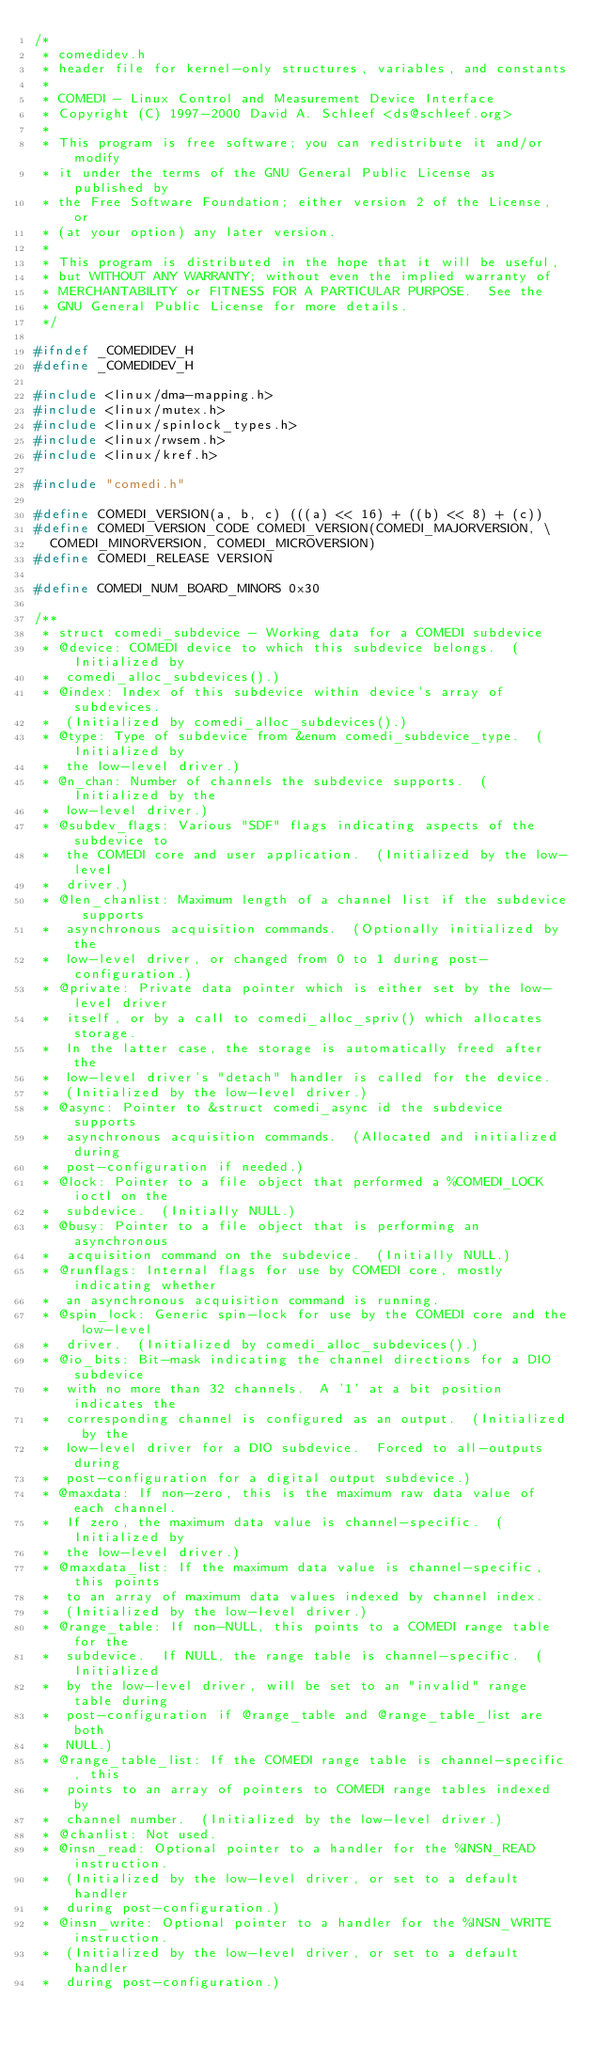Convert code to text. <code><loc_0><loc_0><loc_500><loc_500><_C_>/*
 * comedidev.h
 * header file for kernel-only structures, variables, and constants
 *
 * COMEDI - Linux Control and Measurement Device Interface
 * Copyright (C) 1997-2000 David A. Schleef <ds@schleef.org>
 *
 * This program is free software; you can redistribute it and/or modify
 * it under the terms of the GNU General Public License as published by
 * the Free Software Foundation; either version 2 of the License, or
 * (at your option) any later version.
 *
 * This program is distributed in the hope that it will be useful,
 * but WITHOUT ANY WARRANTY; without even the implied warranty of
 * MERCHANTABILITY or FITNESS FOR A PARTICULAR PURPOSE.  See the
 * GNU General Public License for more details.
 */

#ifndef _COMEDIDEV_H
#define _COMEDIDEV_H

#include <linux/dma-mapping.h>
#include <linux/mutex.h>
#include <linux/spinlock_types.h>
#include <linux/rwsem.h>
#include <linux/kref.h>

#include "comedi.h"

#define COMEDI_VERSION(a, b, c) (((a) << 16) + ((b) << 8) + (c))
#define COMEDI_VERSION_CODE COMEDI_VERSION(COMEDI_MAJORVERSION, \
	COMEDI_MINORVERSION, COMEDI_MICROVERSION)
#define COMEDI_RELEASE VERSION

#define COMEDI_NUM_BOARD_MINORS 0x30

/**
 * struct comedi_subdevice - Working data for a COMEDI subdevice
 * @device: COMEDI device to which this subdevice belongs.  (Initialized by
 *	comedi_alloc_subdevices().)
 * @index: Index of this subdevice within device's array of subdevices.
 *	(Initialized by comedi_alloc_subdevices().)
 * @type: Type of subdevice from &enum comedi_subdevice_type.  (Initialized by
 *	the low-level driver.)
 * @n_chan: Number of channels the subdevice supports.  (Initialized by the
 *	low-level driver.)
 * @subdev_flags: Various "SDF" flags indicating aspects of the subdevice to
 *	the COMEDI core and user application.  (Initialized by the low-level
 *	driver.)
 * @len_chanlist: Maximum length of a channel list if the subdevice supports
 *	asynchronous acquisition commands.  (Optionally initialized by the
 *	low-level driver, or changed from 0 to 1 during post-configuration.)
 * @private: Private data pointer which is either set by the low-level driver
 *	itself, or by a call to comedi_alloc_spriv() which allocates storage.
 *	In the latter case, the storage is automatically freed after the
 *	low-level driver's "detach" handler is called for the device.
 *	(Initialized by the low-level driver.)
 * @async: Pointer to &struct comedi_async id the subdevice supports
 *	asynchronous acquisition commands.  (Allocated and initialized during
 *	post-configuration if needed.)
 * @lock: Pointer to a file object that performed a %COMEDI_LOCK ioctl on the
 *	subdevice.  (Initially NULL.)
 * @busy: Pointer to a file object that is performing an asynchronous
 *	acquisition command on the subdevice.  (Initially NULL.)
 * @runflags: Internal flags for use by COMEDI core, mostly indicating whether
 *	an asynchronous acquisition command is running.
 * @spin_lock: Generic spin-lock for use by the COMEDI core and the low-level
 *	driver.  (Initialized by comedi_alloc_subdevices().)
 * @io_bits: Bit-mask indicating the channel directions for a DIO subdevice
 *	with no more than 32 channels.  A '1' at a bit position indicates the
 *	corresponding channel is configured as an output.  (Initialized by the
 *	low-level driver for a DIO subdevice.  Forced to all-outputs during
 *	post-configuration for a digital output subdevice.)
 * @maxdata: If non-zero, this is the maximum raw data value of each channel.
 *	If zero, the maximum data value is channel-specific.  (Initialized by
 *	the low-level driver.)
 * @maxdata_list: If the maximum data value is channel-specific, this points
 *	to an array of maximum data values indexed by channel index.
 *	(Initialized by the low-level driver.)
 * @range_table: If non-NULL, this points to a COMEDI range table for the
 *	subdevice.  If NULL, the range table is channel-specific.  (Initialized
 *	by the low-level driver, will be set to an "invalid" range table during
 *	post-configuration if @range_table and @range_table_list are both
 *	NULL.)
 * @range_table_list: If the COMEDI range table is channel-specific, this
 *	points to an array of pointers to COMEDI range tables indexed by
 *	channel number.  (Initialized by the low-level driver.)
 * @chanlist: Not used.
 * @insn_read: Optional pointer to a handler for the %INSN_READ instruction.
 *	(Initialized by the low-level driver, or set to a default handler
 *	during post-configuration.)
 * @insn_write: Optional pointer to a handler for the %INSN_WRITE instruction.
 *	(Initialized by the low-level driver, or set to a default handler
 *	during post-configuration.)</code> 